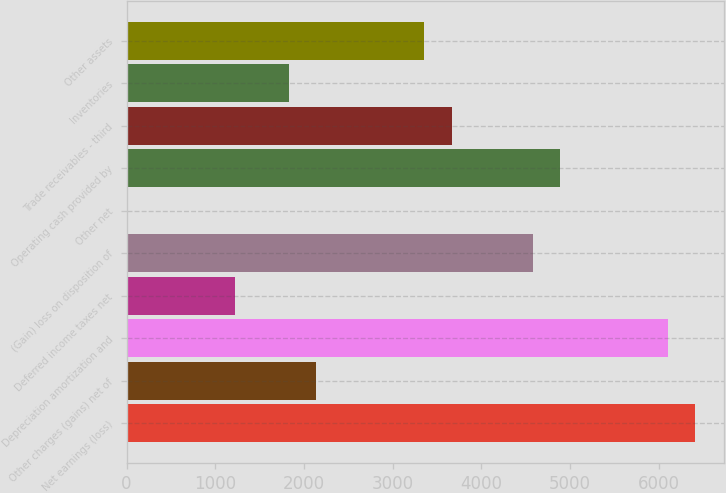<chart> <loc_0><loc_0><loc_500><loc_500><bar_chart><fcel>Net earnings (loss)<fcel>Other charges (gains) net of<fcel>Depreciation amortization and<fcel>Deferred income taxes net<fcel>(Gain) loss on disposition of<fcel>Other net<fcel>Operating cash provided by<fcel>Trade receivables - third<fcel>Inventories<fcel>Other assets<nl><fcel>6409.1<fcel>2137.7<fcel>6104<fcel>1222.4<fcel>4578.5<fcel>2<fcel>4883.6<fcel>3663.2<fcel>1832.6<fcel>3358.1<nl></chart> 